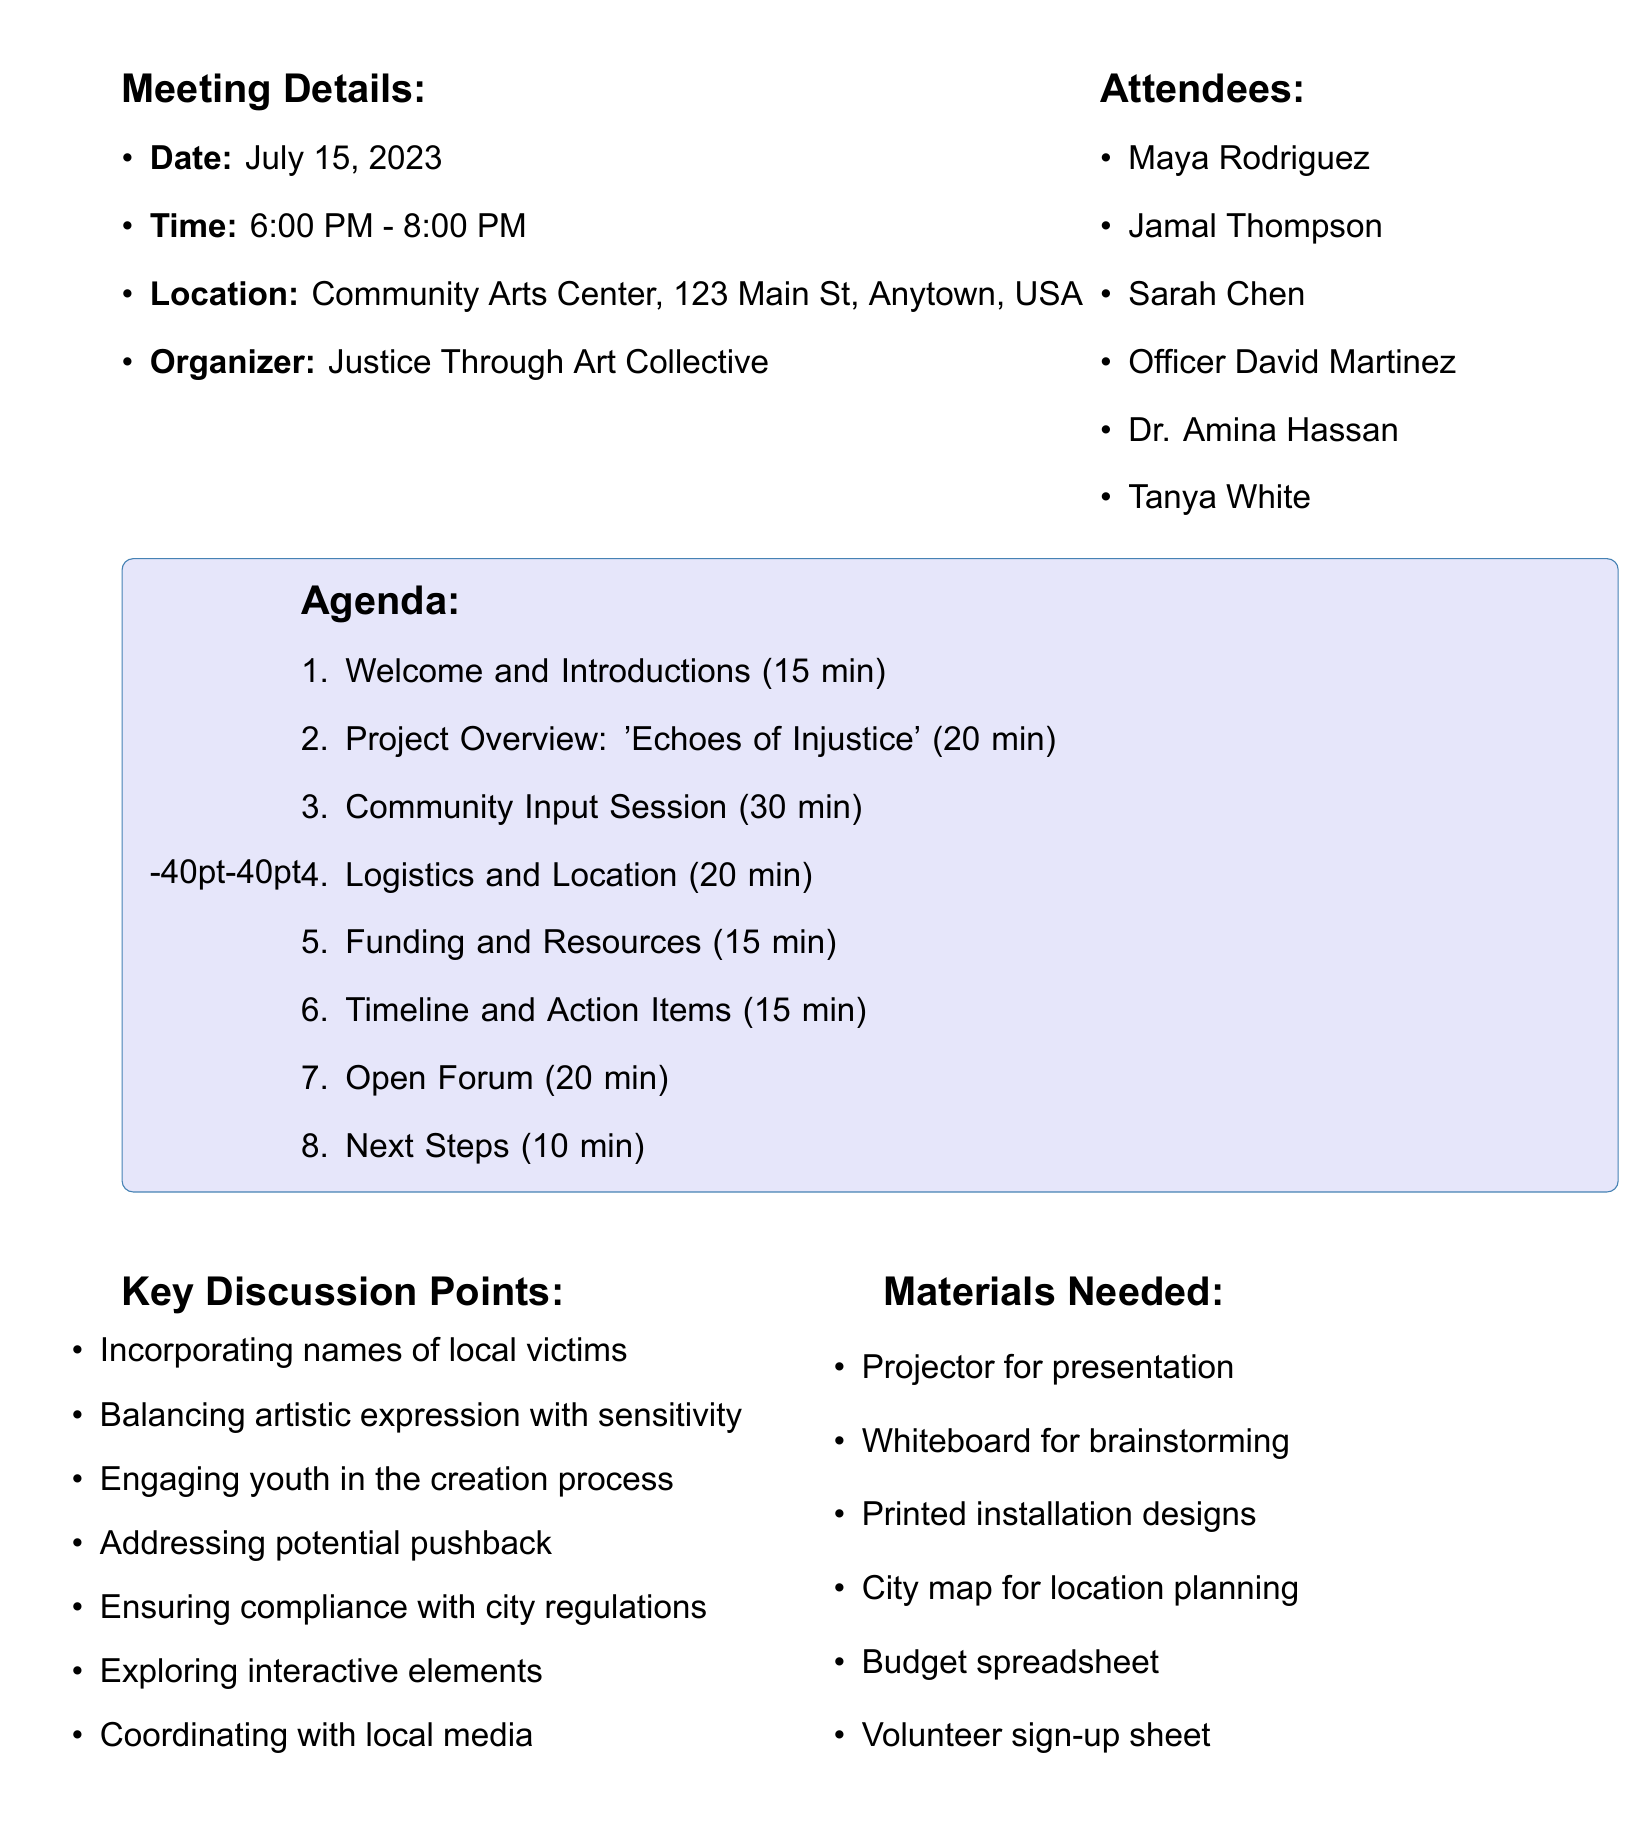What is the date of the meeting? The date of the meeting is explicitly stated in the document.
Answer: July 15, 2023 How long is the Community Input Session? The duration of each agenda item is provided, and this one is specified as 30 minutes.
Answer: 30 minutes Who is the organizer of the meeting? The document names the organizer clearly.
Answer: Justice Through Art Collective What are the two potential installation sites discussed? The document lists the options during the Logistics and Location discussion.
Answer: City Hall Plaza vs. Riverside Park Which attendee represents the Black Lives Matter chapter? The names of attendees are listed, and this role is clear from the document.
Answer: Jamal Thompson What key discussion point relates to youth involvement? The key discussion points highlight strategies for engaging specific groups.
Answer: Engaging youth in the creation process How much time is allocated for the Open Forum? The duration for each agenda item is listed, and the duration for this item is found in the agenda.
Answer: 20 minutes What is one material needed for the meeting? The materials needed are explicitly listed in the document.
Answer: Projector for presentation 